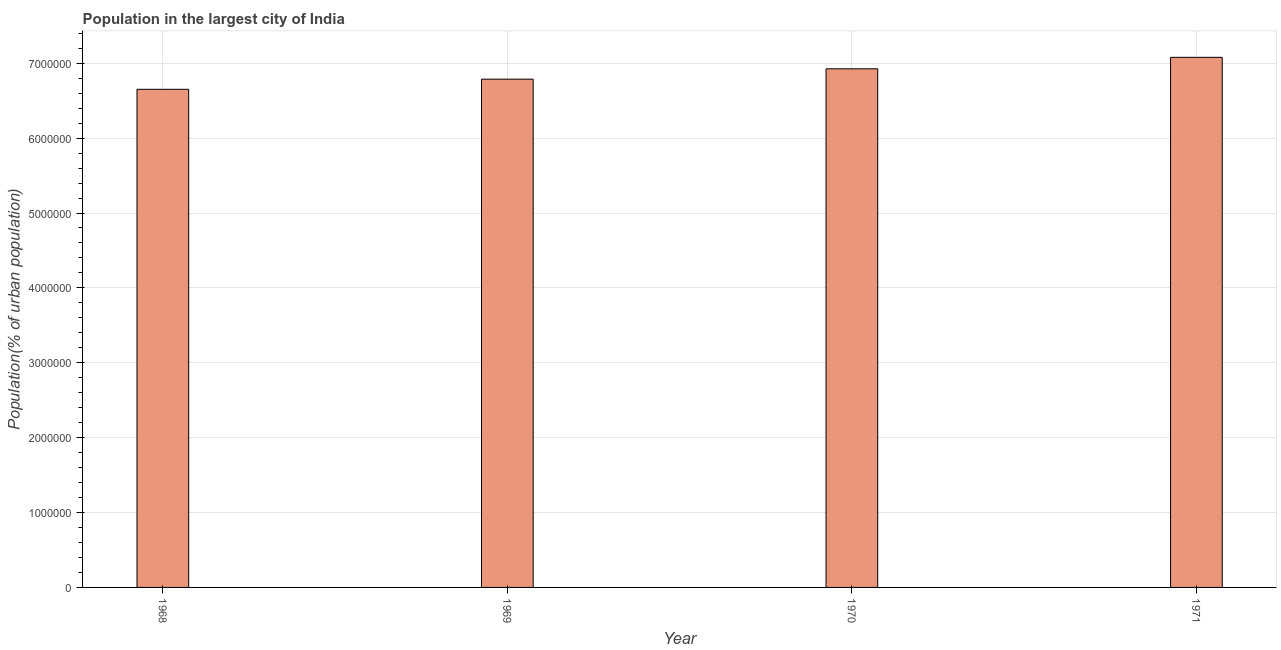What is the title of the graph?
Provide a succinct answer. Population in the largest city of India. What is the label or title of the Y-axis?
Offer a very short reply. Population(% of urban population). What is the population in largest city in 1970?
Provide a short and direct response. 6.93e+06. Across all years, what is the maximum population in largest city?
Ensure brevity in your answer.  7.08e+06. Across all years, what is the minimum population in largest city?
Keep it short and to the point. 6.65e+06. In which year was the population in largest city maximum?
Provide a succinct answer. 1971. In which year was the population in largest city minimum?
Provide a short and direct response. 1968. What is the sum of the population in largest city?
Make the answer very short. 2.74e+07. What is the difference between the population in largest city in 1968 and 1970?
Give a very brief answer. -2.74e+05. What is the average population in largest city per year?
Provide a short and direct response. 6.86e+06. What is the median population in largest city?
Keep it short and to the point. 6.86e+06. Do a majority of the years between 1968 and 1969 (inclusive) have population in largest city greater than 4800000 %?
Provide a succinct answer. Yes. Is the difference between the population in largest city in 1968 and 1970 greater than the difference between any two years?
Offer a terse response. No. What is the difference between the highest and the second highest population in largest city?
Make the answer very short. 1.53e+05. Is the sum of the population in largest city in 1968 and 1970 greater than the maximum population in largest city across all years?
Your answer should be very brief. Yes. What is the difference between the highest and the lowest population in largest city?
Ensure brevity in your answer.  4.27e+05. In how many years, is the population in largest city greater than the average population in largest city taken over all years?
Provide a succinct answer. 2. How many bars are there?
Your answer should be compact. 4. What is the difference between two consecutive major ticks on the Y-axis?
Your response must be concise. 1.00e+06. What is the Population(% of urban population) of 1968?
Ensure brevity in your answer.  6.65e+06. What is the Population(% of urban population) of 1969?
Keep it short and to the point. 6.79e+06. What is the Population(% of urban population) of 1970?
Keep it short and to the point. 6.93e+06. What is the Population(% of urban population) of 1971?
Keep it short and to the point. 7.08e+06. What is the difference between the Population(% of urban population) in 1968 and 1969?
Provide a short and direct response. -1.35e+05. What is the difference between the Population(% of urban population) in 1968 and 1970?
Provide a short and direct response. -2.74e+05. What is the difference between the Population(% of urban population) in 1968 and 1971?
Your answer should be very brief. -4.27e+05. What is the difference between the Population(% of urban population) in 1969 and 1970?
Keep it short and to the point. -1.38e+05. What is the difference between the Population(% of urban population) in 1969 and 1971?
Provide a short and direct response. -2.92e+05. What is the difference between the Population(% of urban population) in 1970 and 1971?
Your answer should be compact. -1.53e+05. What is the ratio of the Population(% of urban population) in 1968 to that in 1970?
Provide a succinct answer. 0.96. What is the ratio of the Population(% of urban population) in 1969 to that in 1970?
Offer a terse response. 0.98. What is the ratio of the Population(% of urban population) in 1969 to that in 1971?
Your answer should be compact. 0.96. What is the ratio of the Population(% of urban population) in 1970 to that in 1971?
Keep it short and to the point. 0.98. 